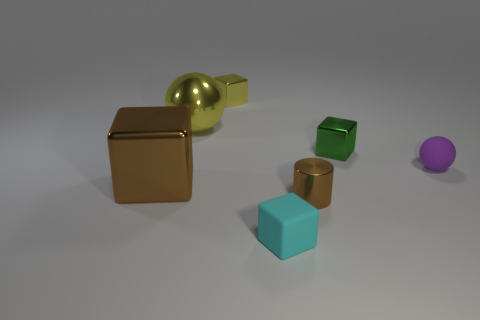Subtract all yellow metallic blocks. How many blocks are left? 3 Subtract all blocks. How many objects are left? 3 Subtract all yellow blocks. How many blocks are left? 3 Subtract 1 cylinders. How many cylinders are left? 0 Add 7 green metallic things. How many green metallic things exist? 8 Add 3 tiny blue matte blocks. How many objects exist? 10 Subtract 0 gray spheres. How many objects are left? 7 Subtract all gray spheres. Subtract all red cubes. How many spheres are left? 2 Subtract all cyan spheres. How many green blocks are left? 1 Subtract all large cyan rubber balls. Subtract all shiny spheres. How many objects are left? 6 